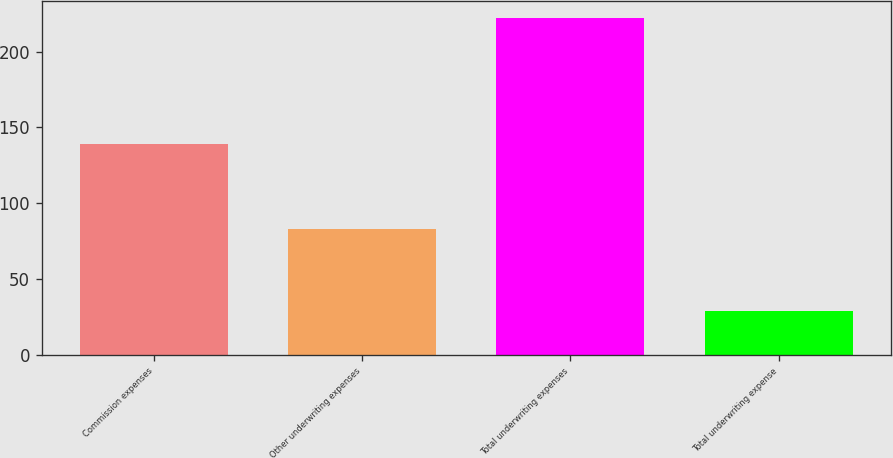Convert chart to OTSL. <chart><loc_0><loc_0><loc_500><loc_500><bar_chart><fcel>Commission expenses<fcel>Other underwriting expenses<fcel>Total underwriting expenses<fcel>Total underwriting expense<nl><fcel>139<fcel>83<fcel>222<fcel>29.1<nl></chart> 